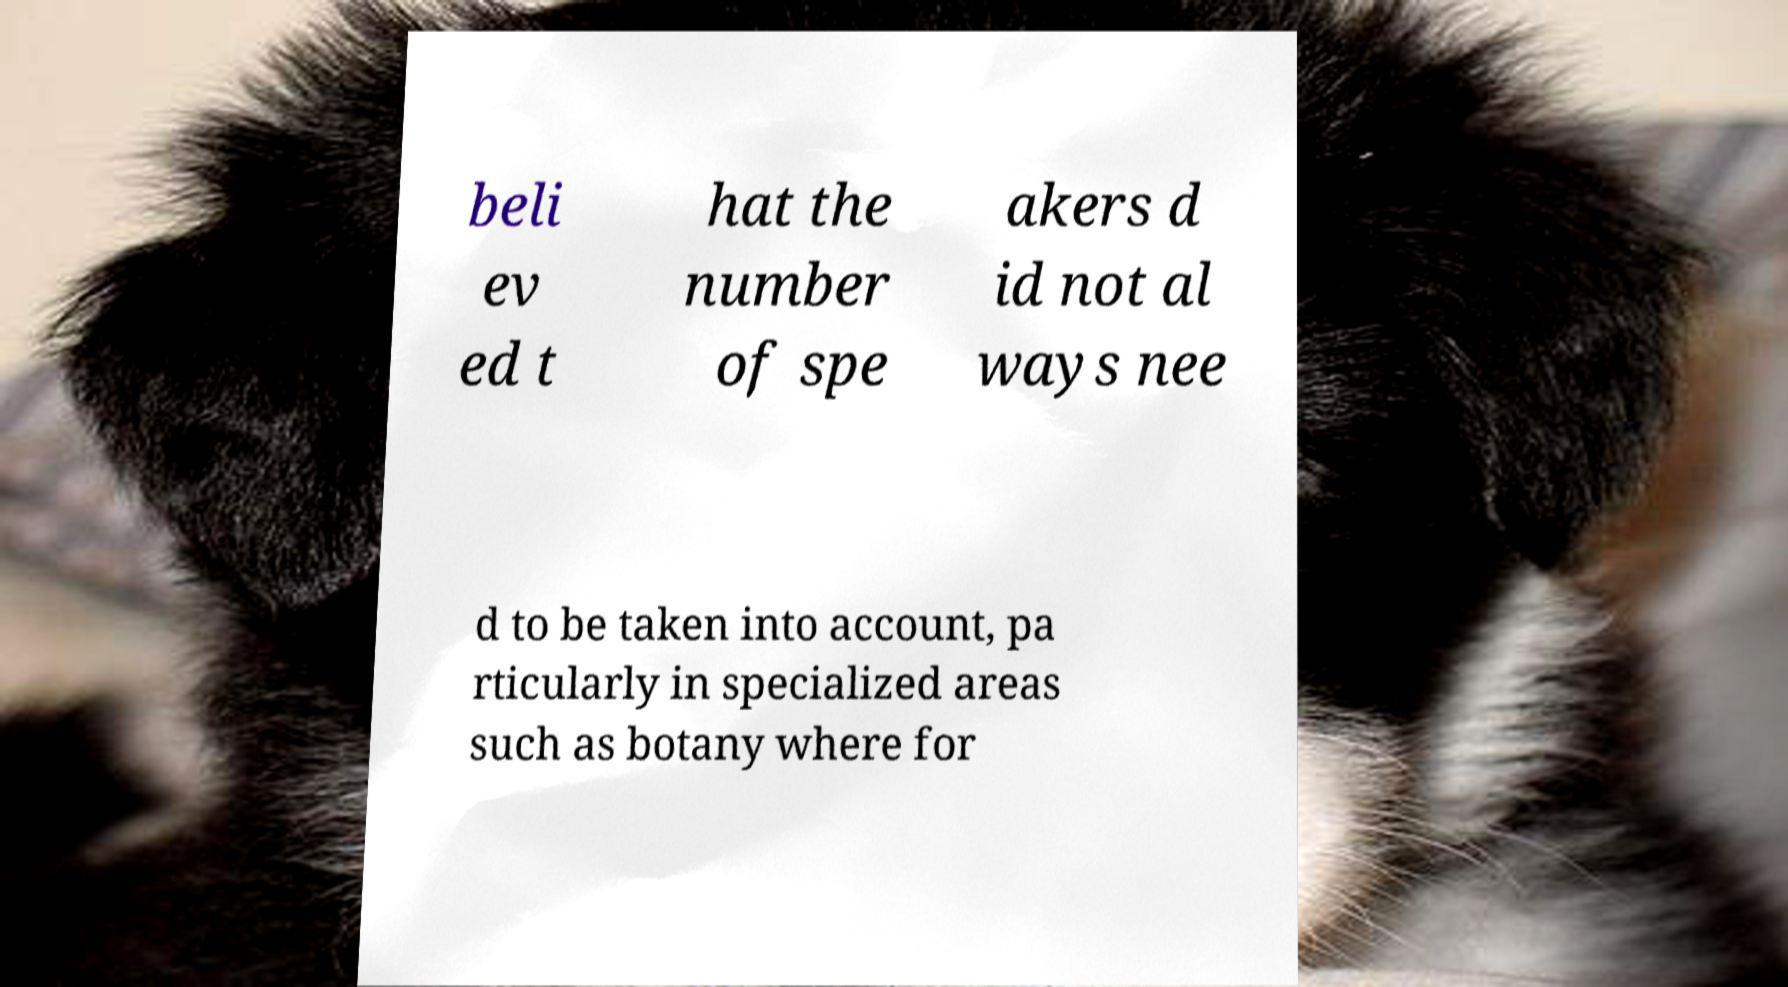Please identify and transcribe the text found in this image. beli ev ed t hat the number of spe akers d id not al ways nee d to be taken into account, pa rticularly in specialized areas such as botany where for 